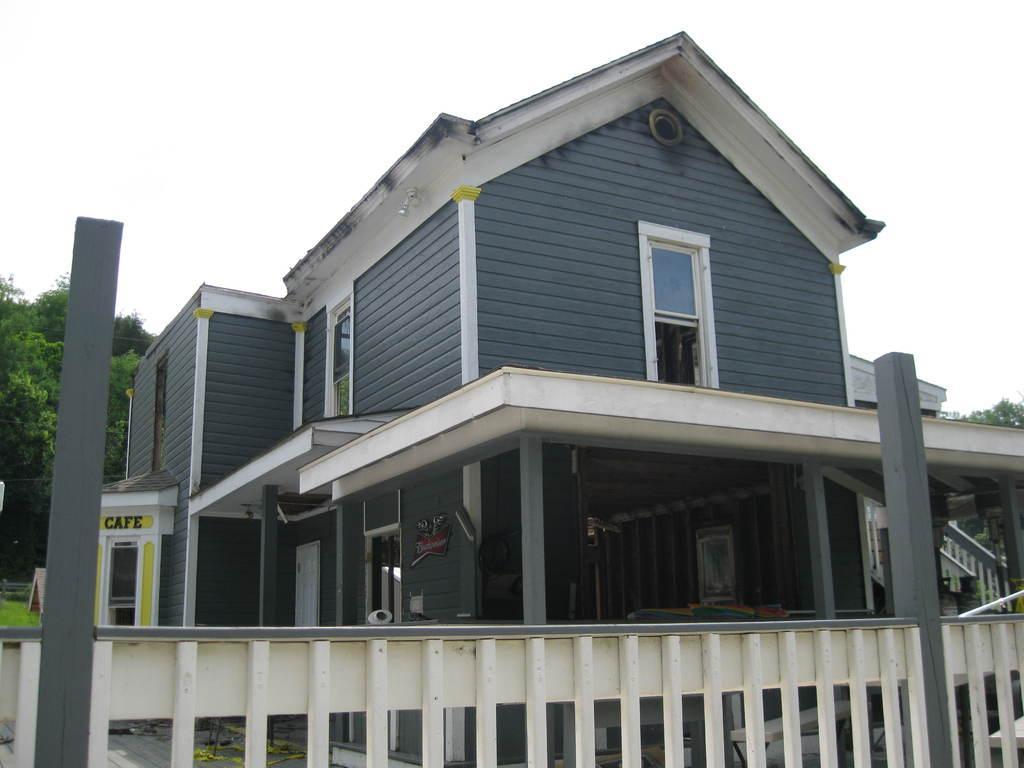Could you give a brief overview of what you see in this image? In the picture we can see a house with windows and glasses to it and the house is gray in color and to the roof, we can see white in color and near the house we can see railing which is white in color and some poles to it which are gray in color and beside the house we can see a shop to it and written on it as cafe and beside we can see a grass surface and some trees on it and behind it we can see a sky with clouds. 